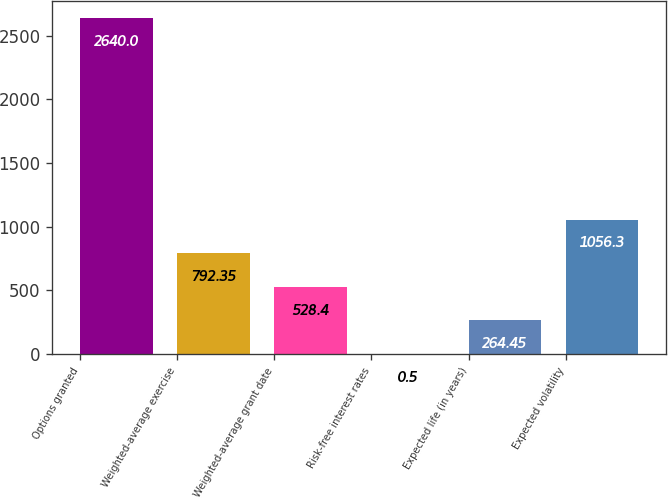Convert chart to OTSL. <chart><loc_0><loc_0><loc_500><loc_500><bar_chart><fcel>Options granted<fcel>Weighted-average exercise<fcel>Weighted-average grant date<fcel>Risk-free interest rates<fcel>Expected life (in years)<fcel>Expected volatility<nl><fcel>2640<fcel>792.35<fcel>528.4<fcel>0.5<fcel>264.45<fcel>1056.3<nl></chart> 